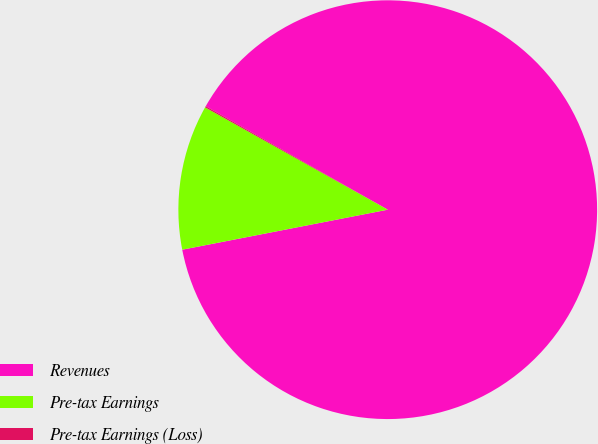<chart> <loc_0><loc_0><loc_500><loc_500><pie_chart><fcel>Revenues<fcel>Pre-tax Earnings<fcel>Pre-tax Earnings (Loss)<nl><fcel>88.71%<fcel>11.19%<fcel>0.1%<nl></chart> 